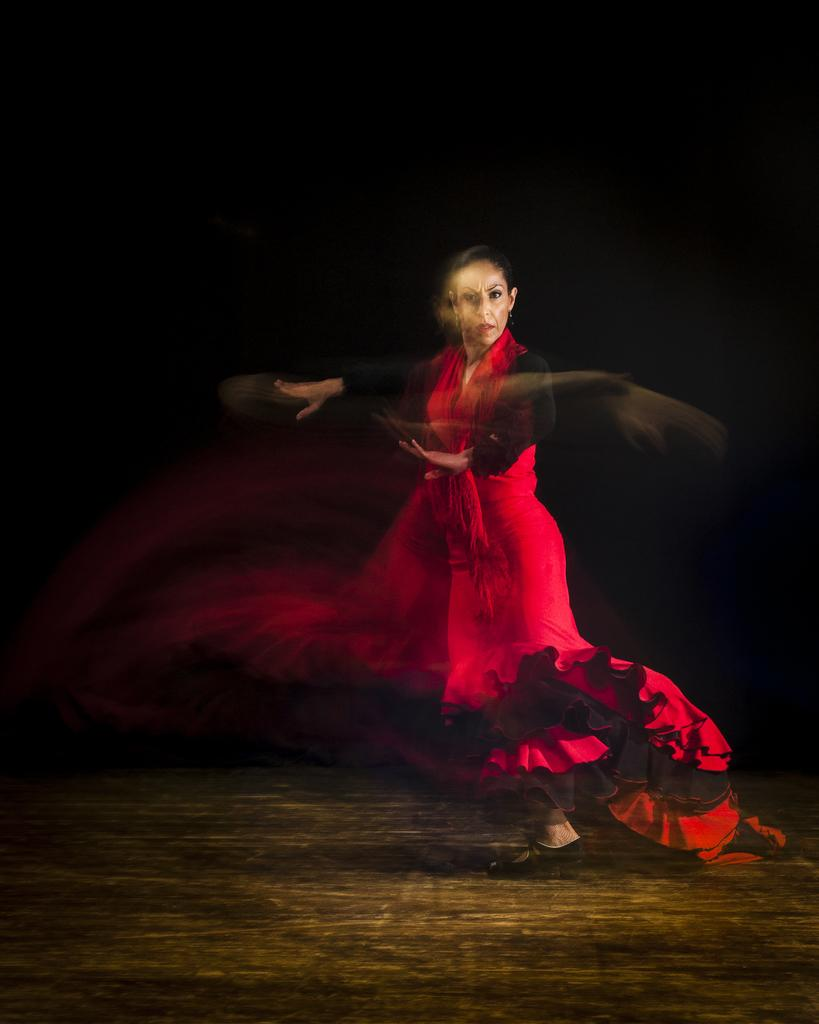Who is the main subject in the picture? There is a woman in the picture. What is the woman wearing? The woman is wearing a red and black color dress. What is the woman doing in the picture? The woman is dancing. Can you see the seashore in the background of the picture? There is no mention of a seashore in the provided facts, and therefore it cannot be determined if it is present in the image. 